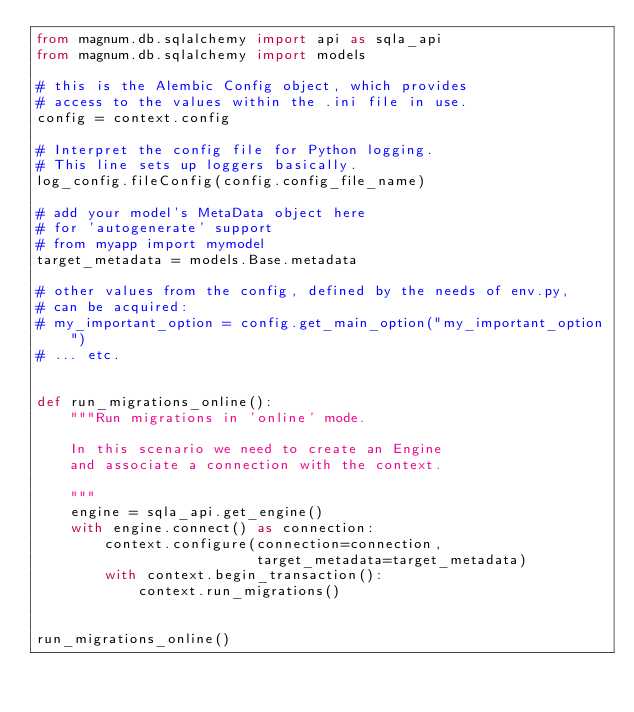Convert code to text. <code><loc_0><loc_0><loc_500><loc_500><_Python_>from magnum.db.sqlalchemy import api as sqla_api
from magnum.db.sqlalchemy import models

# this is the Alembic Config object, which provides
# access to the values within the .ini file in use.
config = context.config

# Interpret the config file for Python logging.
# This line sets up loggers basically.
log_config.fileConfig(config.config_file_name)

# add your model's MetaData object here
# for 'autogenerate' support
# from myapp import mymodel
target_metadata = models.Base.metadata

# other values from the config, defined by the needs of env.py,
# can be acquired:
# my_important_option = config.get_main_option("my_important_option")
# ... etc.


def run_migrations_online():
    """Run migrations in 'online' mode.

    In this scenario we need to create an Engine
    and associate a connection with the context.

    """
    engine = sqla_api.get_engine()
    with engine.connect() as connection:
        context.configure(connection=connection,
                          target_metadata=target_metadata)
        with context.begin_transaction():
            context.run_migrations()


run_migrations_online()
</code> 